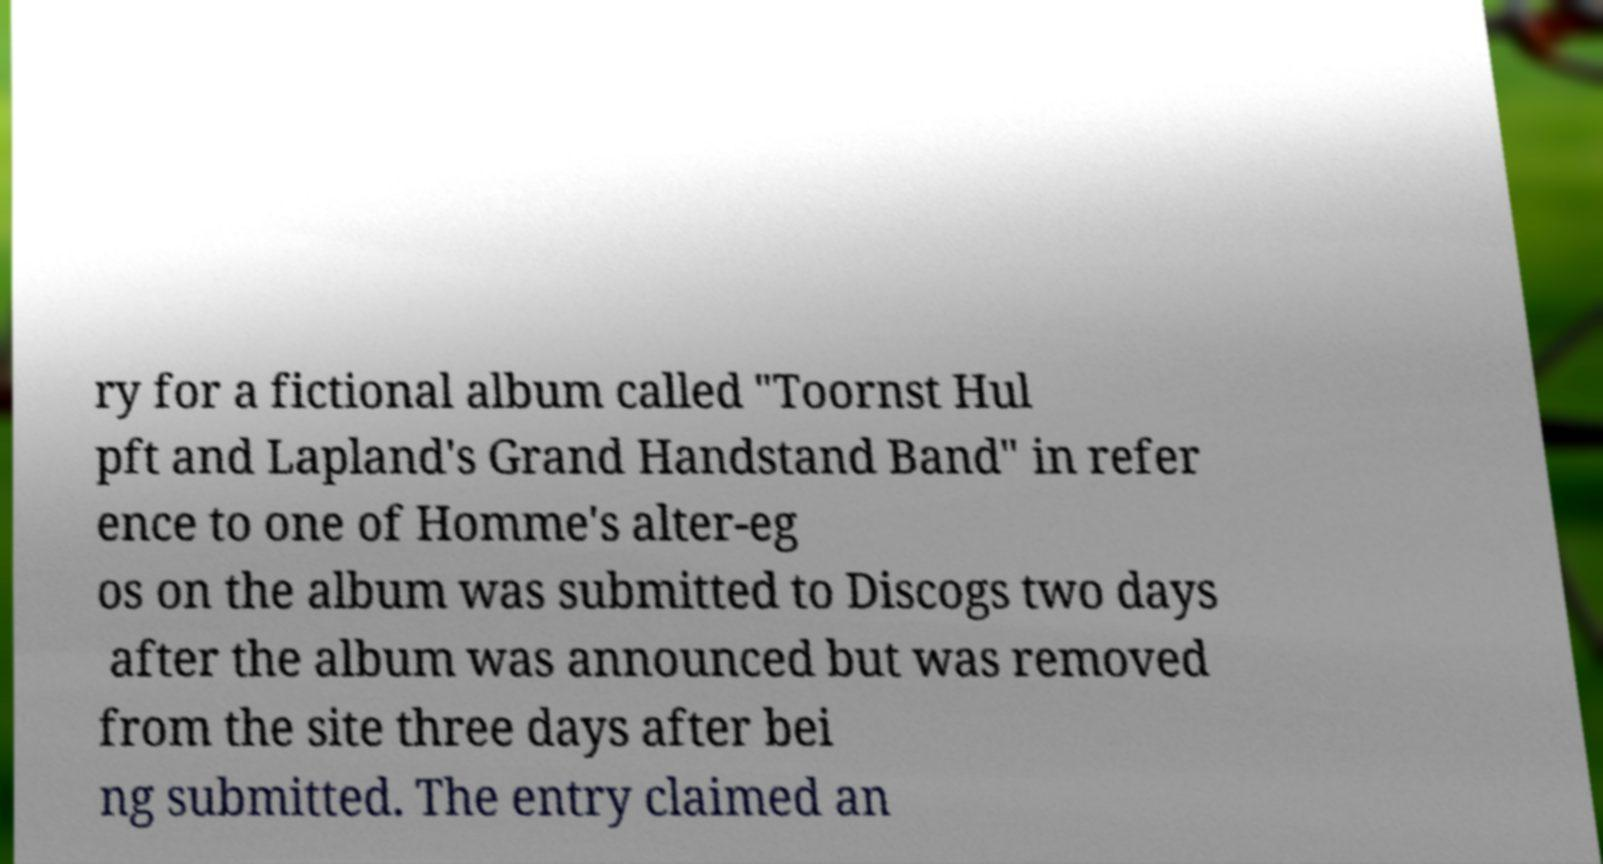Can you read and provide the text displayed in the image?This photo seems to have some interesting text. Can you extract and type it out for me? ry for a fictional album called "Toornst Hul pft and Lapland's Grand Handstand Band" in refer ence to one of Homme's alter-eg os on the album was submitted to Discogs two days after the album was announced but was removed from the site three days after bei ng submitted. The entry claimed an 